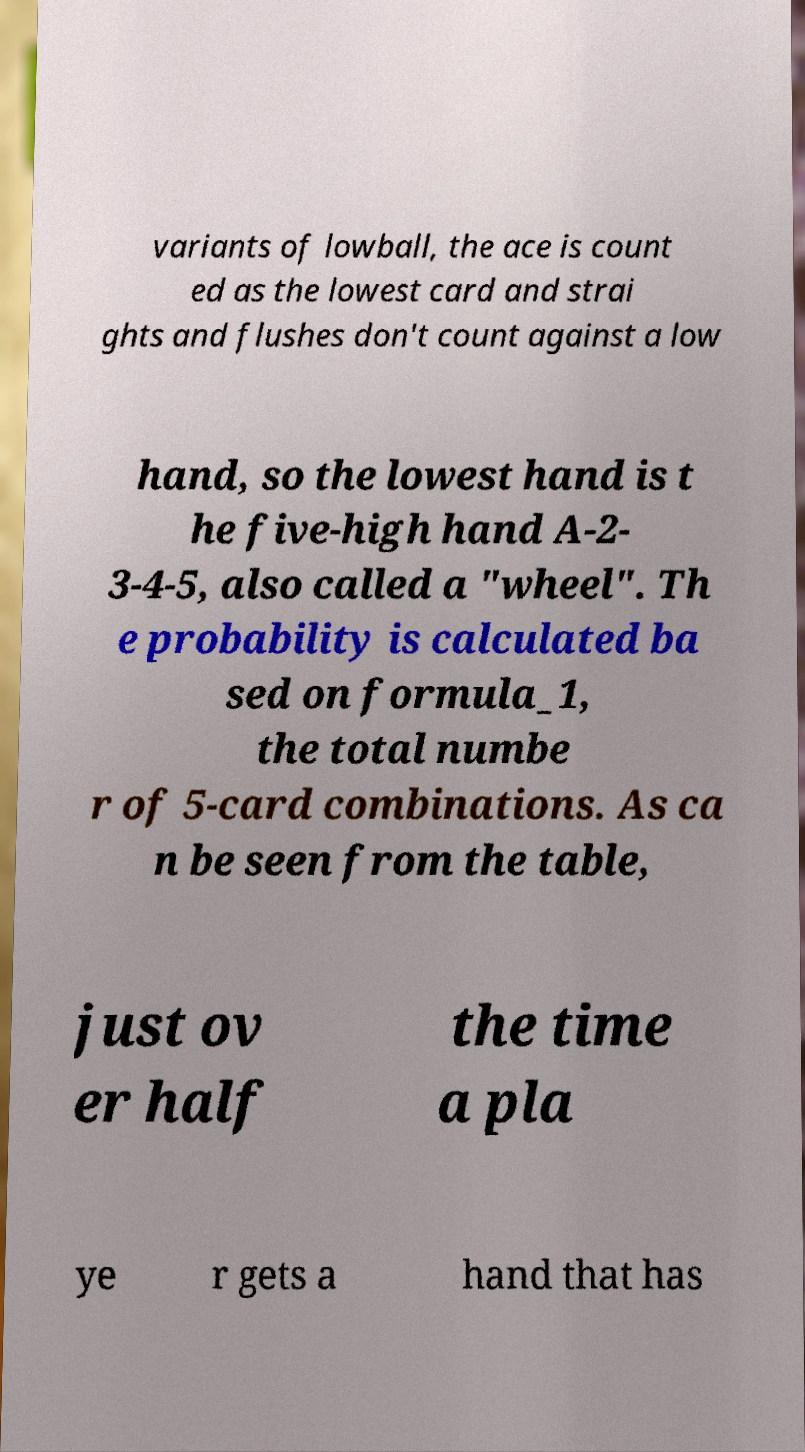Could you assist in decoding the text presented in this image and type it out clearly? variants of lowball, the ace is count ed as the lowest card and strai ghts and flushes don't count against a low hand, so the lowest hand is t he five-high hand A-2- 3-4-5, also called a "wheel". Th e probability is calculated ba sed on formula_1, the total numbe r of 5-card combinations. As ca n be seen from the table, just ov er half the time a pla ye r gets a hand that has 